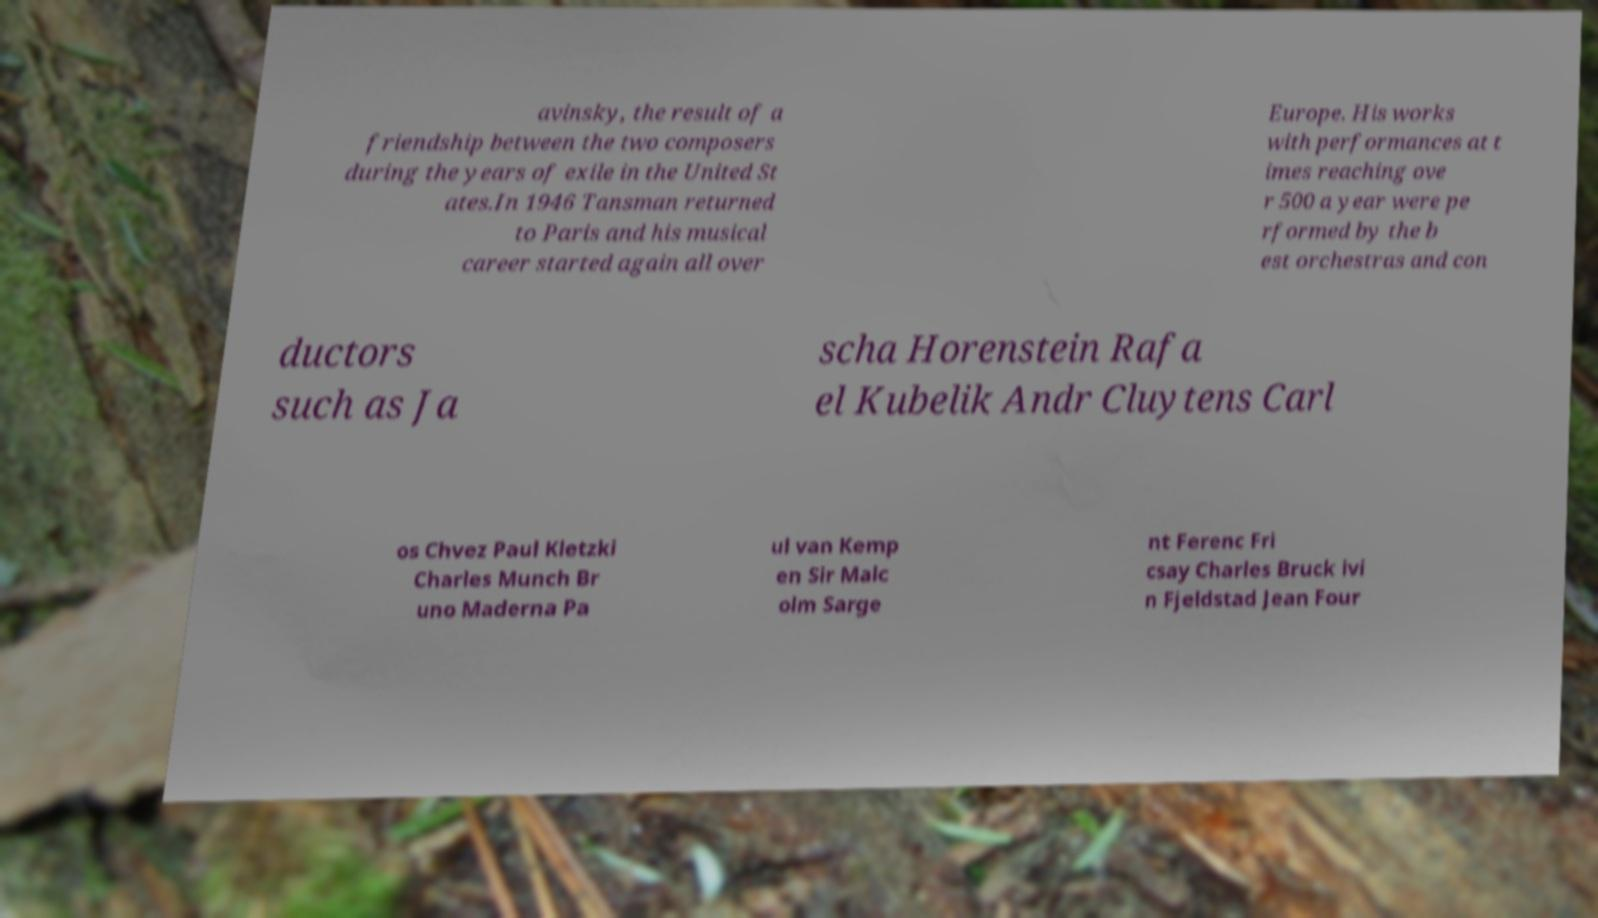Could you assist in decoding the text presented in this image and type it out clearly? avinsky, the result of a friendship between the two composers during the years of exile in the United St ates.In 1946 Tansman returned to Paris and his musical career started again all over Europe. His works with performances at t imes reaching ove r 500 a year were pe rformed by the b est orchestras and con ductors such as Ja scha Horenstein Rafa el Kubelik Andr Cluytens Carl os Chvez Paul Kletzki Charles Munch Br uno Maderna Pa ul van Kemp en Sir Malc olm Sarge nt Ferenc Fri csay Charles Bruck ivi n Fjeldstad Jean Four 